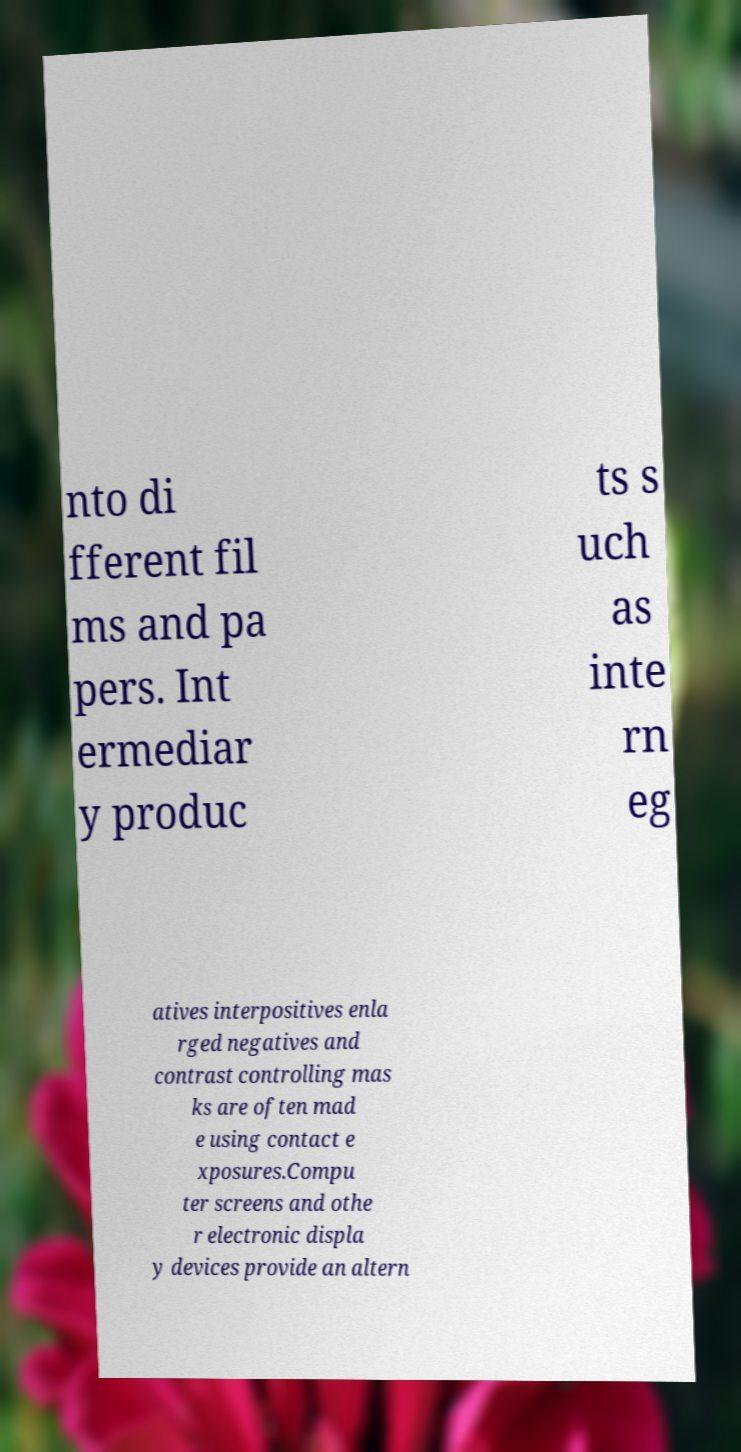Could you assist in decoding the text presented in this image and type it out clearly? nto di fferent fil ms and pa pers. Int ermediar y produc ts s uch as inte rn eg atives interpositives enla rged negatives and contrast controlling mas ks are often mad e using contact e xposures.Compu ter screens and othe r electronic displa y devices provide an altern 